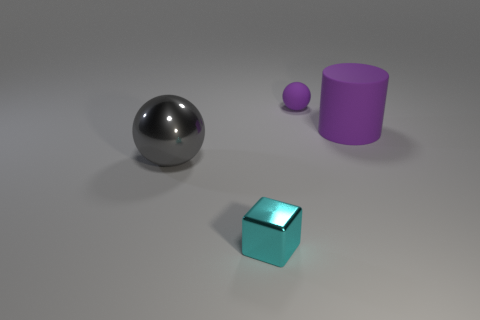What shape is the small object that is behind the metal ball? The small object situated behind the metal ball appears to be a sphere. It resembles a scaled-down version of the metal ball, albeit in a purple hue, suggesting it might be a small rubber ball or a similarly textured object. 